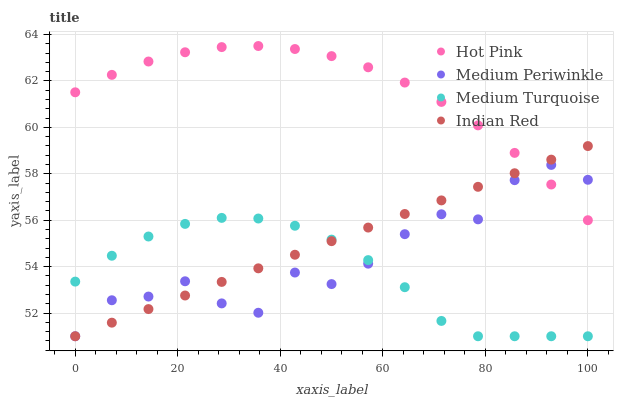Does Medium Turquoise have the minimum area under the curve?
Answer yes or no. Yes. Does Hot Pink have the maximum area under the curve?
Answer yes or no. Yes. Does Medium Periwinkle have the minimum area under the curve?
Answer yes or no. No. Does Medium Periwinkle have the maximum area under the curve?
Answer yes or no. No. Is Indian Red the smoothest?
Answer yes or no. Yes. Is Medium Periwinkle the roughest?
Answer yes or no. Yes. Is Medium Periwinkle the smoothest?
Answer yes or no. No. Is Indian Red the roughest?
Answer yes or no. No. Does Medium Periwinkle have the lowest value?
Answer yes or no. Yes. Does Hot Pink have the highest value?
Answer yes or no. Yes. Does Medium Periwinkle have the highest value?
Answer yes or no. No. Is Medium Turquoise less than Hot Pink?
Answer yes or no. Yes. Is Hot Pink greater than Medium Turquoise?
Answer yes or no. Yes. Does Hot Pink intersect Indian Red?
Answer yes or no. Yes. Is Hot Pink less than Indian Red?
Answer yes or no. No. Is Hot Pink greater than Indian Red?
Answer yes or no. No. Does Medium Turquoise intersect Hot Pink?
Answer yes or no. No. 